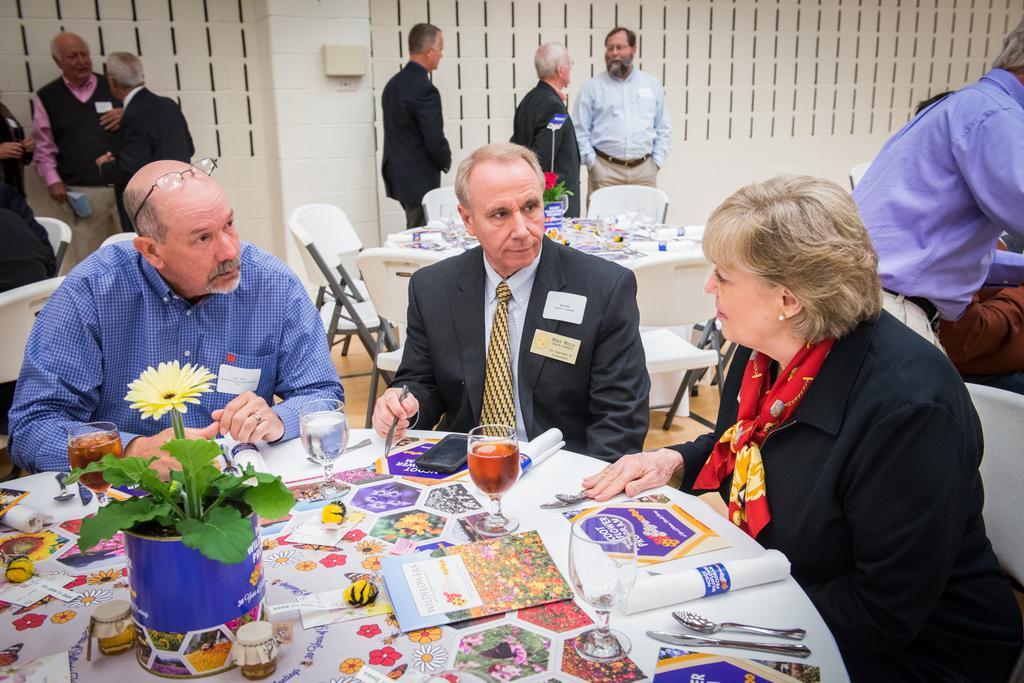Can you describe this image briefly? In this picture we can see a group of men and women sitting at the round table. In the front there is a flower pot, papers and wine glasses. Behind there are some persons standing and discussing something. In the background we can see a white wall. 